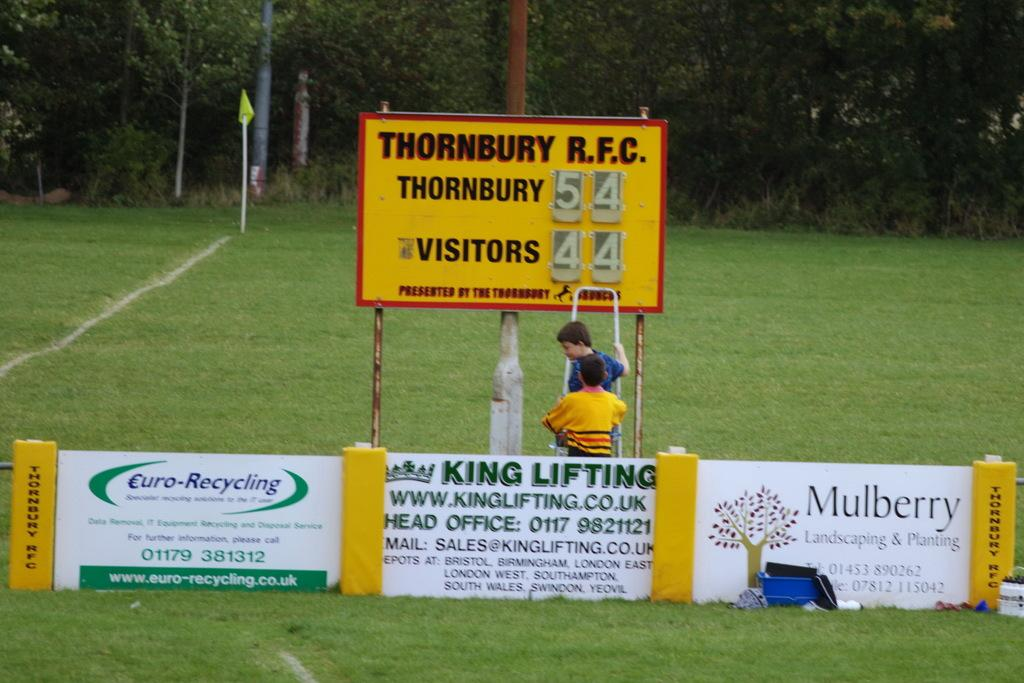<image>
Provide a brief description of the given image. A sporting event is taking place and Thornbury is beating the visitors 54 to 44. 